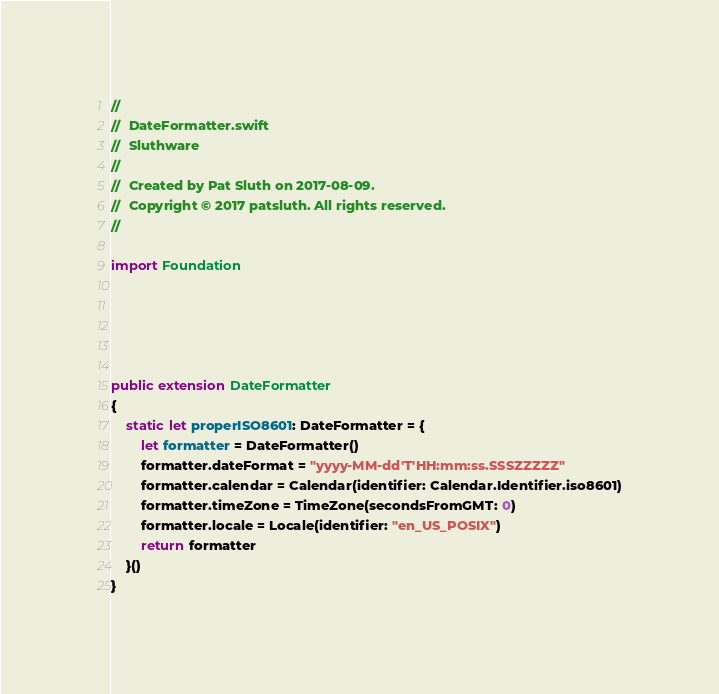Convert code to text. <code><loc_0><loc_0><loc_500><loc_500><_Swift_>//
//  DateFormatter.swift
//  Sluthware
//
//  Created by Pat Sluth on 2017-08-09.
//  Copyright © 2017 patsluth. All rights reserved.
//

import Foundation





public extension DateFormatter
{
	static let properISO8601: DateFormatter = {
		let formatter = DateFormatter()
		formatter.dateFormat = "yyyy-MM-dd'T'HH:mm:ss.SSSZZZZZ"
		formatter.calendar = Calendar(identifier: Calendar.Identifier.iso8601)
		formatter.timeZone = TimeZone(secondsFromGMT: 0)
		formatter.locale = Locale(identifier: "en_US_POSIX")
		return formatter
	}()
}




</code> 